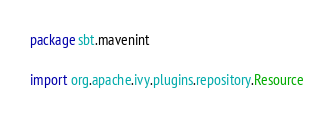Convert code to text. <code><loc_0><loc_0><loc_500><loc_500><_Scala_>package sbt.mavenint

import org.apache.ivy.plugins.repository.Resource</code> 